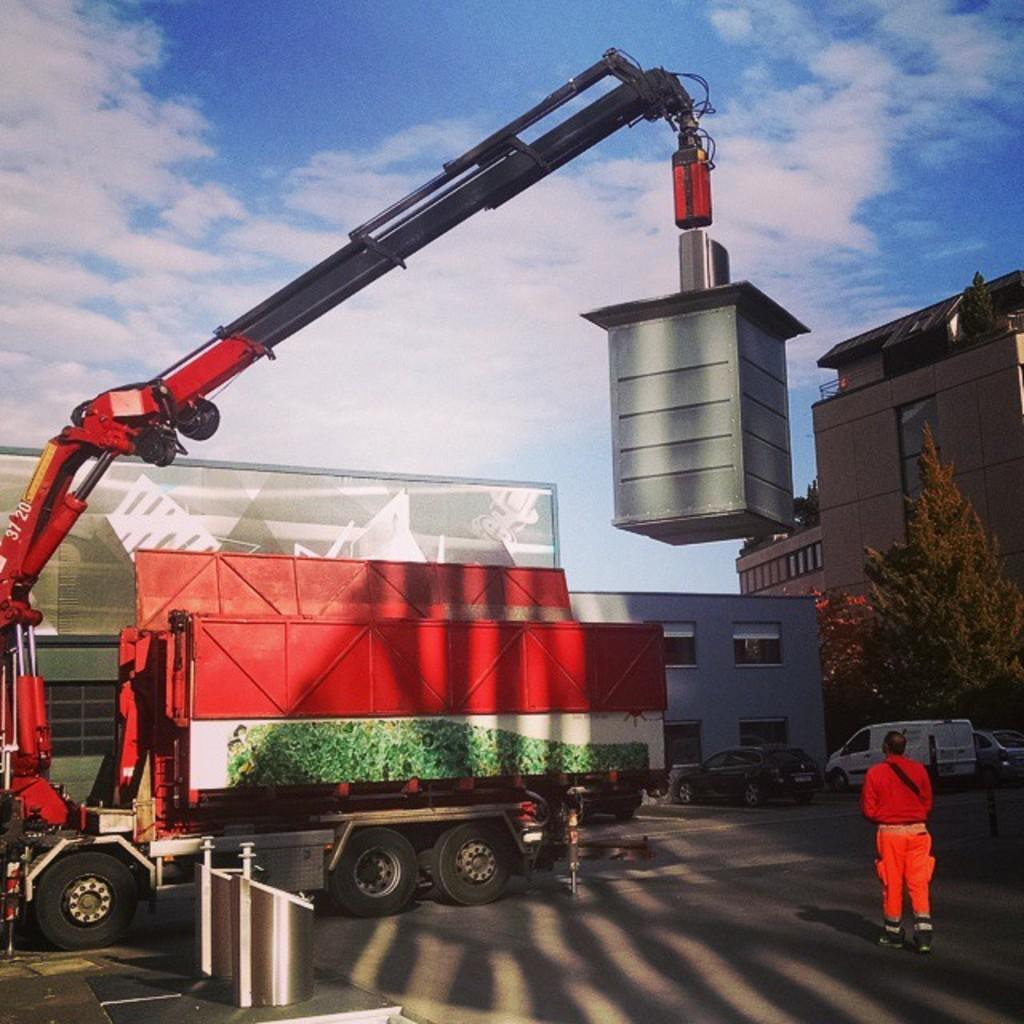<image>
Render a clear and concise summary of the photo. Man standing by a red machine that says the numbers 3720. 